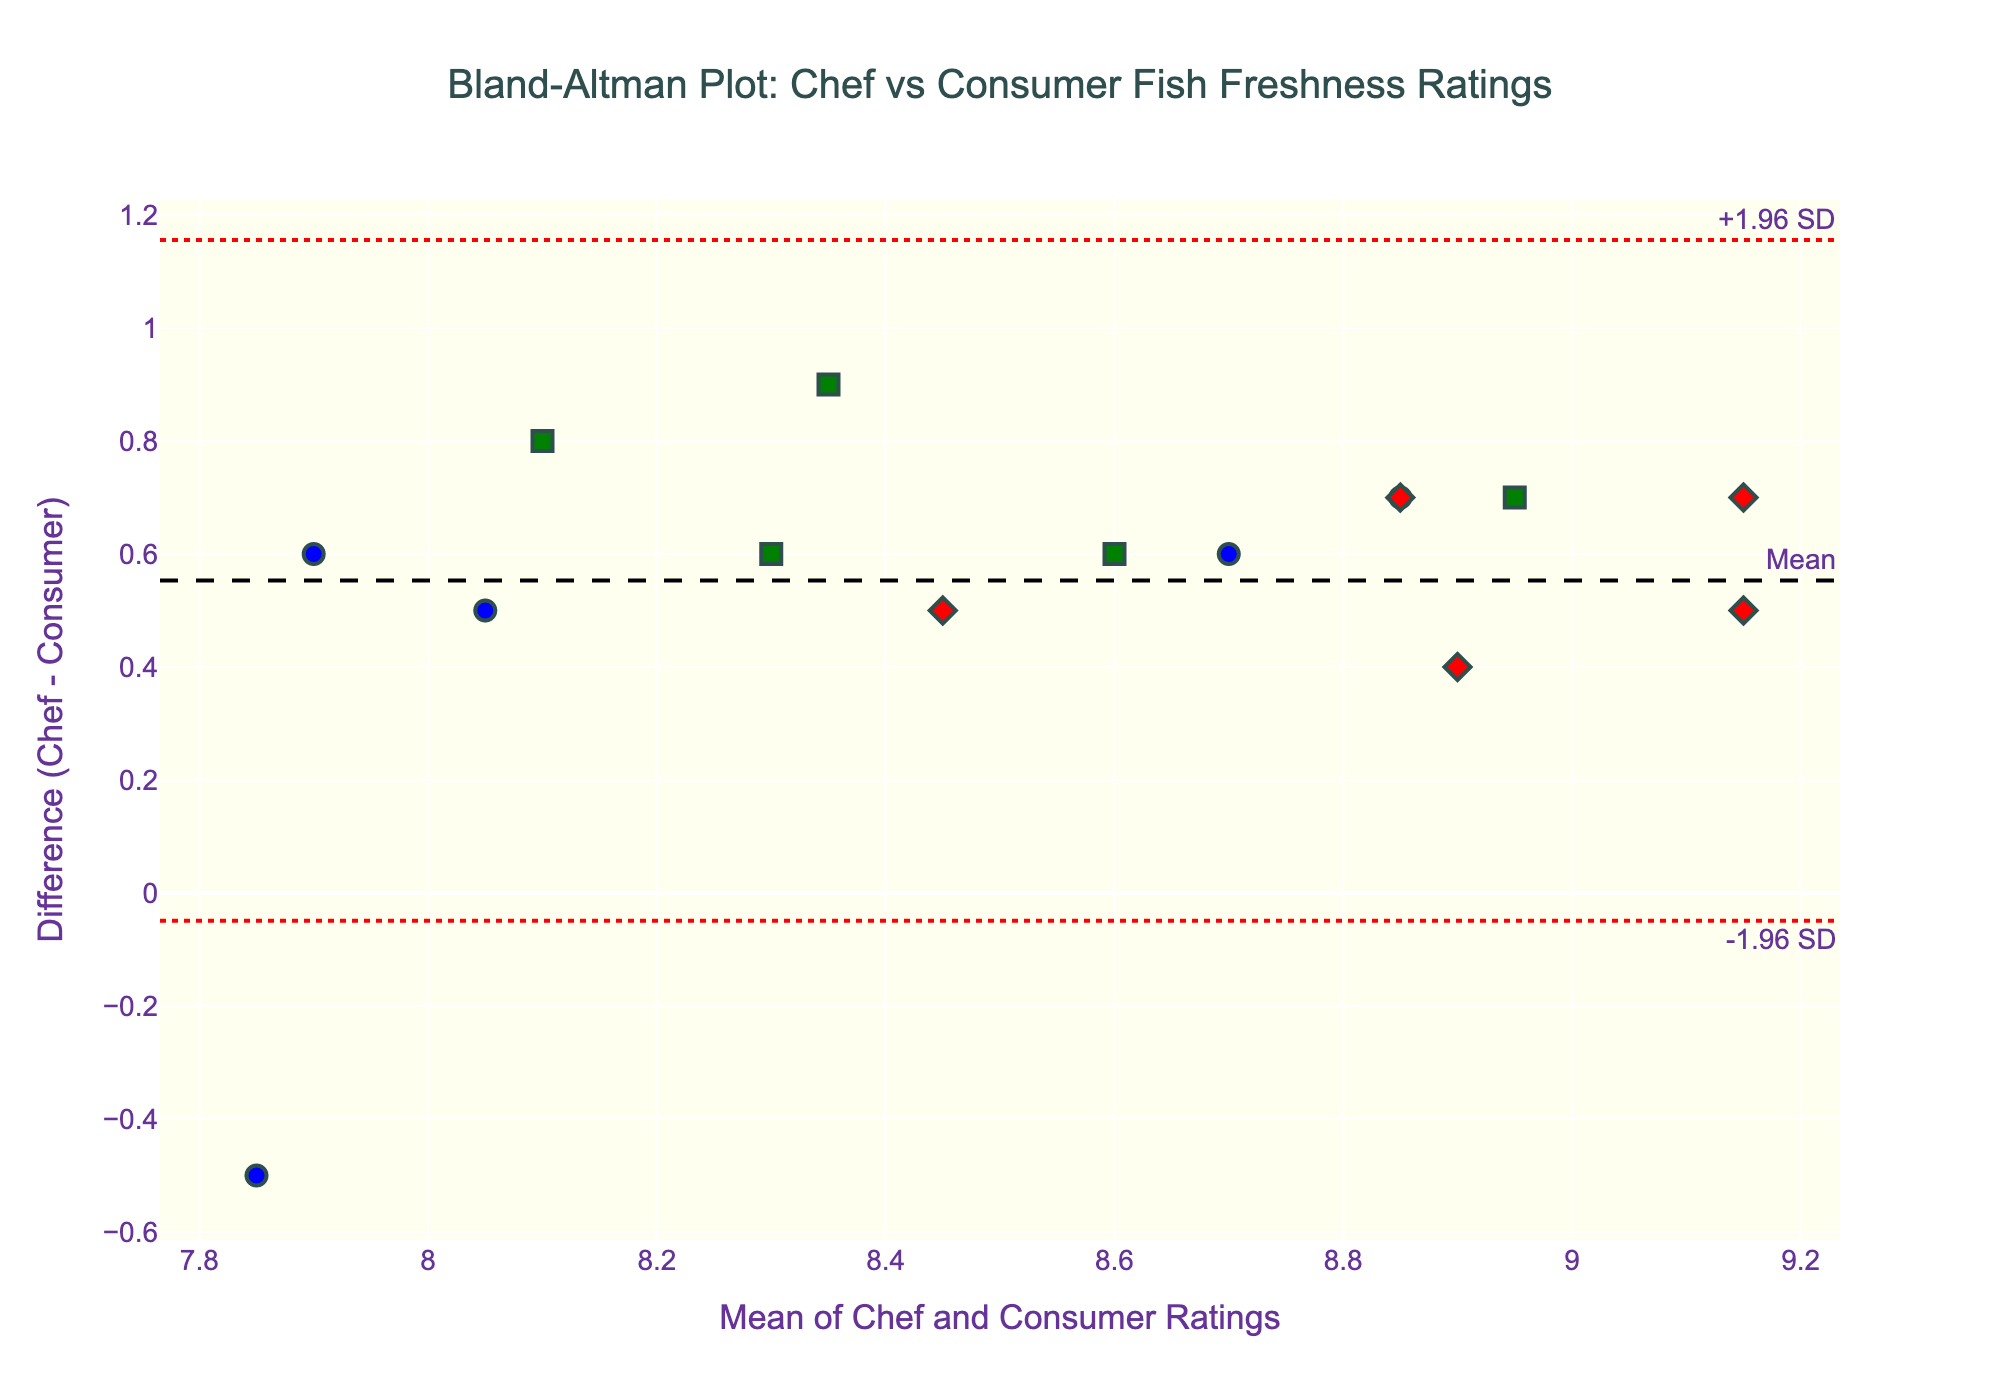What is the title of the figure? The title appears at the top of the figure. It reads, "Bland-Altman Plot: Chef vs Consumer Fish Freshness Ratings."
Answer: Bland-Altman Plot: Chef vs Consumer Fish Freshness Ratings What do the x and y axes represent in the plot? The x-axis represents the "Mean of Chef and Consumer Ratings," while the y-axis represents the "Difference (Chef - Consumer)." These labels are clearly displayed along the axes.
Answer: Mean of Chef and Consumer Ratings (x-axis), Difference (Chef - Consumer) (y-axis) How many storage methods are represented in the plot, and what are they? By looking at the color and shape of the markers in the legend, we can see there are three storage methods: Ice (blue circles), Refrigerated (green squares), and Vacuum-sealed (red diamonds).
Answer: Three (Ice, Refrigerated, Vacuum-sealed) Which storage method shows the highest frequency of data points? Identify the markers and their respective storage methods. The storage method with the most markers is 'Ice,' represented by blue circles.
Answer: Ice What is the mean difference in ratings between chefs and consumers? The mean difference is represented by the dashed horizontal line labeled "Mean." This is positioned roughly at 0.6 on the y-axis.
Answer: Approximately 0.6 Are there any fish species that consumers rated higher than chefs? If yes, which ones? Check for markers below the x-axis because these would have a negative y-axis value (Chef - Consumer). The fish species associated with these markers (when hovering) include Tilapia and Trout.
Answer: Tilapia, Trout Which storage method is closer to the mean difference line more often? Observe which color markers are closely clustered around the mean difference horizontal line. The 'Vacuum-sealed' (red diamonds) markers appear closer to the mean difference line more frequently.
Answer: Vacuum-sealed What are the lower and upper limits of agreement in the plot? The lower limit of agreement is the dotted line labeled "-1.96 SD" at approximately -0.52, and the upper limit is the dotted line labeled "+1.96 SD" at approximately 1.72.
Answer: -0.52 (lower), 1.72 (upper) Which fish species has the highest mean rating (mean of chef and consumer ratings)? Locate the marker with the highest x-axis value; this value corresponds to mean ratings. Hovering over the marker, we find the fish species is Tuna.
Answer: Tuna What is the range of the differences in ratings for fish stored on ice? Identify the blue circle markers and check their range on the y-axis, the lowest value being around -0.5 and the highest around 0.6. Thus, the range is approximately (0.6 - (-0.5)).
Answer: 1.1 